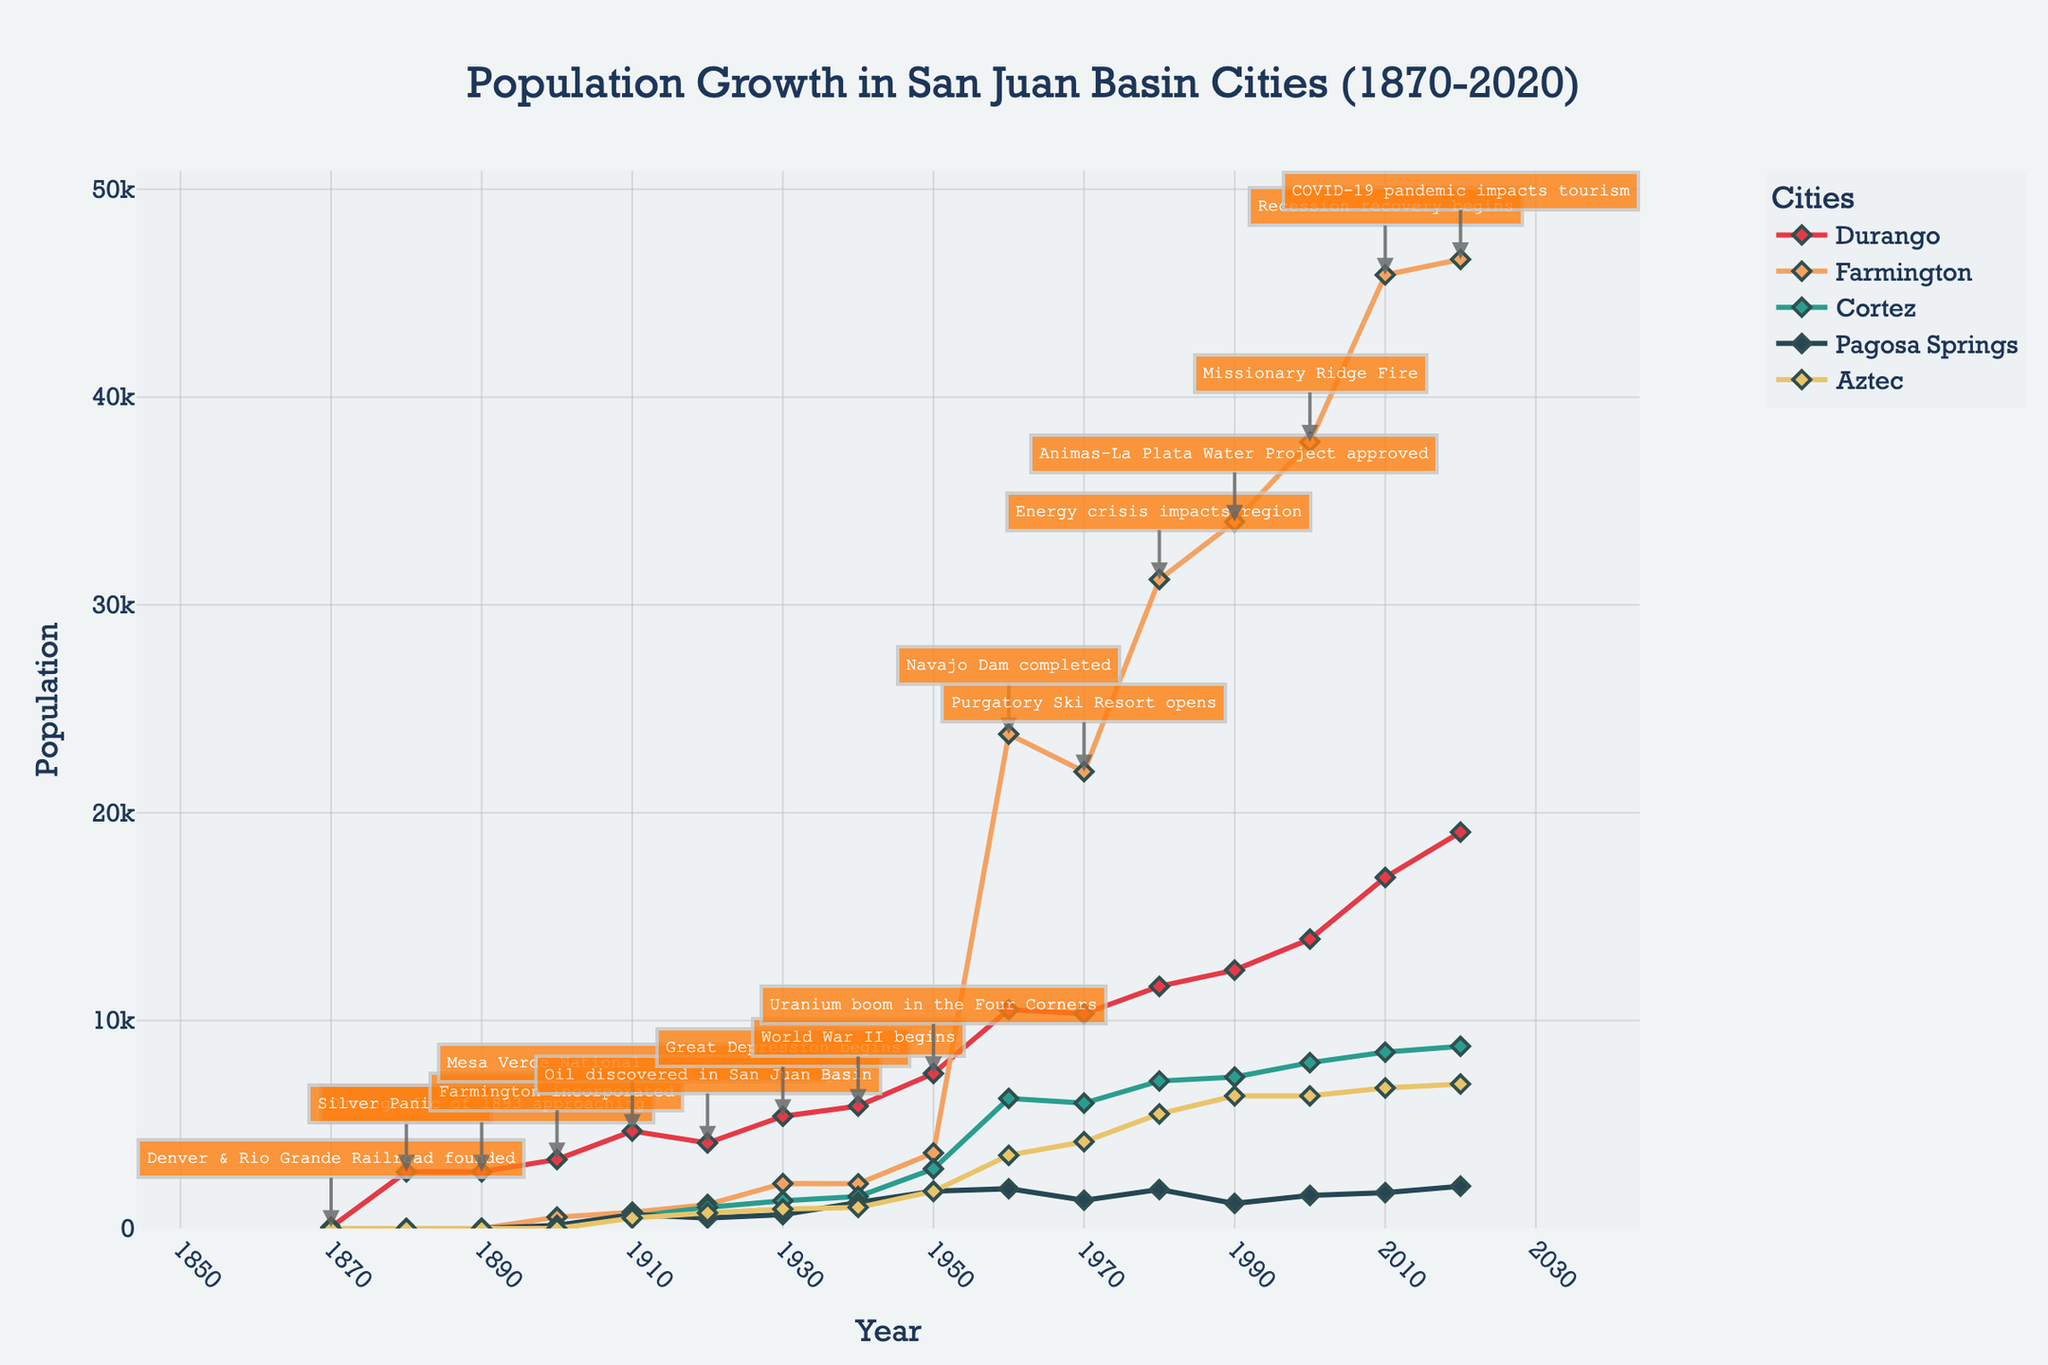What key historical event occurred around the time Durango's population first appears on the chart? To answer this, find the year Durango's population first appears and check the annotation for that year. Durango's population first appears in 1880, and the annotation for that year is "Durango founded".
Answer: Durango founded Comparing the populations in 1950, which city had the highest population among Durango, Farmington, Cortez, Pagosa Springs, and Aztec? To determine this, look at the population values for each specified city in 1950 and identify the highest value. Farmington had the highest population of 3637 in 1950.
Answer: Farmington How did the population of Durango change between 1920 and 1930? Find the population values for Durango in both 1920 and 1930, then calculate the difference. The population increased from 4116 to 5400, which is an increase of 1284.
Answer: Increased by 1284 What historical event is annotated at its highest population spike for Farmington in the 1960s? Find the peak population spike for Farmington in the 1960s and read the corresponding annotation. For 1960, Farmington had a notable population of 23786 with the annotation "Navajo Dam completed".
Answer: Navajo Dam completed Which city had the smallest population in the year 1890? Examine the population values for each city in 1890 to identify the smallest one. All cities except Durango have a population of 0 in 1890, so the smallest population is 0.
Answer: All except Durango had 0 During the Great Depression beginning in 1930, which city among Durango, Farmington, Cortez, Pagosa Springs, and Aztec had the highest recorded population? Look at the population counts for each city in the year 1930, and identify the highest one. Durango had the highest population in 1930 with a count of 5400.
Answer: Durango From 2000 to 2010, how much did Cortez's population grow, and what were the key historical events in that period? Find Cortez's population for 2000 and 2010, calculate the increase, and check for annotations in that period. The population grew from 7977 to 8482, an increase of 505. The key events were the "Missionary Ridge Fire" in 2000 and "Recession recovery begins" in 2010.
Answer: Increased by 505, Missionary Ridge Fire and Recession recovery begins What was the population difference between Durango and Cortez in 2020? Find the populations of Durango and Cortez in 2020 and subtract Cortez's population from Durango's. Durango had 19071, and Cortez had 8766. The difference is 19071 - 8766 = 10305.
Answer: 10305 What visible trend can be seen in the population of Farmington from 1960 to 2020? Observe the population values for Farmington from 1960 to 2020 and describe the trend visible in the figure. Farmington shows a sharp increase in population from 1960 to 1980, followed by continued growth but at a slower rate.
Answer: Sharp increase then slower growth Which city experienced a significant population gain during the Uranium boom in the 1950s? Identify the city with the most notable population gain between 1940 and 1950 by checking their population values. Farmington's population increased significantly from 2151 in 1940 to 3637 in 1950.
Answer: Farmington 